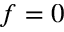<formula> <loc_0><loc_0><loc_500><loc_500>f = 0</formula> 